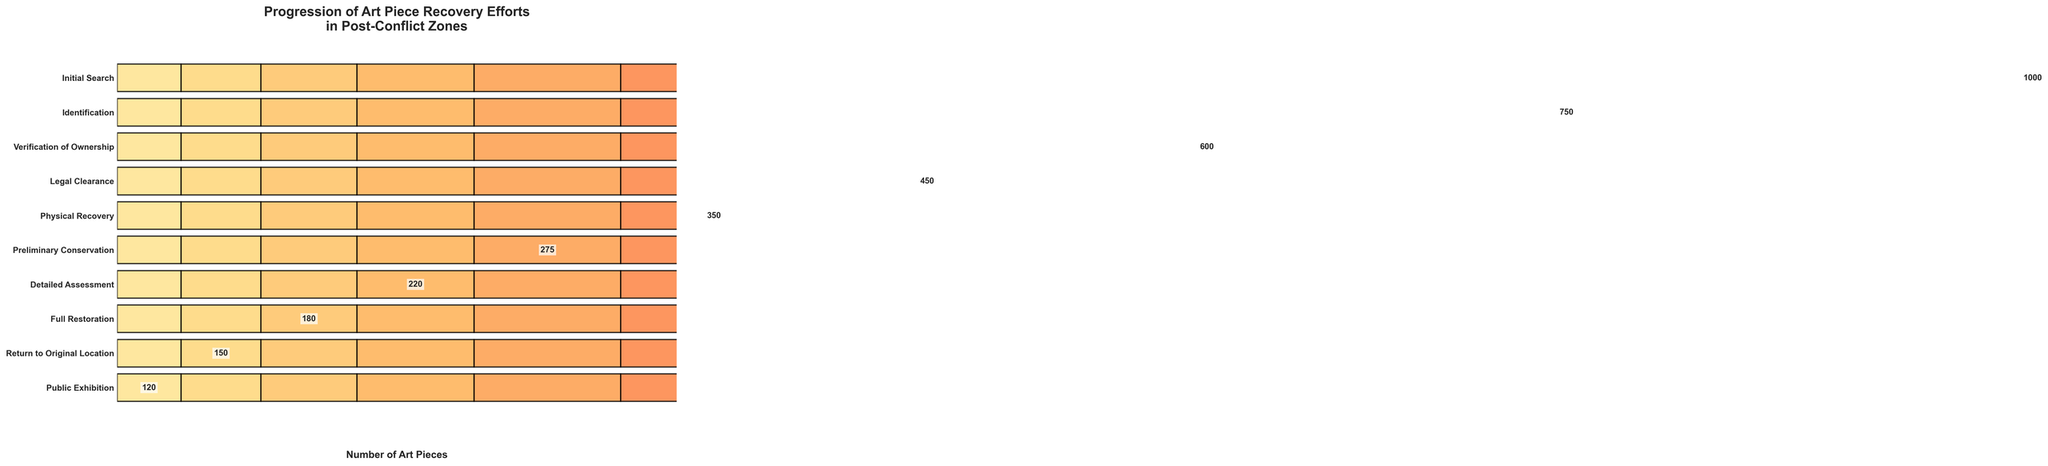What is the title of the chart? The title is located at the top of the chart and provides a brief summary of the figure's content. In this case, it reads "Progression of Art Piece Recovery Efforts in Post-Conflict Zones".
Answer: Progression of Art Piece Recovery Efforts in Post-Conflict Zones How many stages are involved in the art piece recovery process? The number of stages can be determined by counting the unique entries listed on the vertical axis of the chart. Each bar represents a different stage.
Answer: 10 Which stage has the lowest number of art pieces? This can be identified by looking for the shortest bar on the horizontal scale, and the associated label on the vertical axis. Here, the shortest bar corresponds to the "Public Exhibition" stage.
Answer: Public Exhibition How many art pieces are lost between the "Initial Search" and "Identification" stages? Subtract the number of art pieces identified (750) from the initial search (1000). 1000 - 750 = 250 pieces are lost during this transition.
Answer: 250 What is the total number of art pieces lost from "Verification of Ownership" to "Return to Original Location"? This requires calculating the difference between the number of art pieces at each mentioned stage and summing them up: (600 - 450) + (450 - 350) + (350 - 275) + (275 - 220) + (220 - 180) + (180 - 150). The total is 150 + 100 + 75 + 55 + 40 + 30 = 450 pieces.
Answer: 450 Which stage experiences the largest drop in the number of art pieces from the previous stage? By examining the differences between adjacent stages, we find the largest drop occurs between "Legal Clearance" (450 pieces) and "Physical Recovery" (350 pieces), corresponding to a drop of 100 pieces.
Answer: Legal Clearance to Physical Recovery How many stages retain more than 500 art pieces? Reviewing the data, only the "Initial Search", "Identification", and "Verification of Ownership" stages have more than 500 art pieces, so there are three stages.
Answer: 3 What is the difference in the number of art pieces between "Preliminary Conservation" and "Full Restoration"? Subtract the number of pieces in "Full Restoration" (180) from those in "Preliminary Conservation" (275): 275 - 180 = 95 pieces.
Answer: 95 Which two adjacent stages have the least difference in the number of art pieces? By computing the differences between adjacent stage pairs, the smallest is between "Detailed Assessment" (220) and "Full Restoration" (180), with a difference of 40 pieces.
Answer: Detailed Assessment to Full Restoration How many art pieces are left unaccounted for by the end of public exhibition? Subtract the final number of pieces in Public Exhibition (120) from the initial search number (1000): 1000 - 120 = 880 pieces.
Answer: 880 